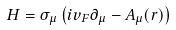<formula> <loc_0><loc_0><loc_500><loc_500>H = \sigma _ { \mu } \left ( i v _ { F } \partial _ { \mu } - A _ { \mu } ( { r } ) \right )</formula> 